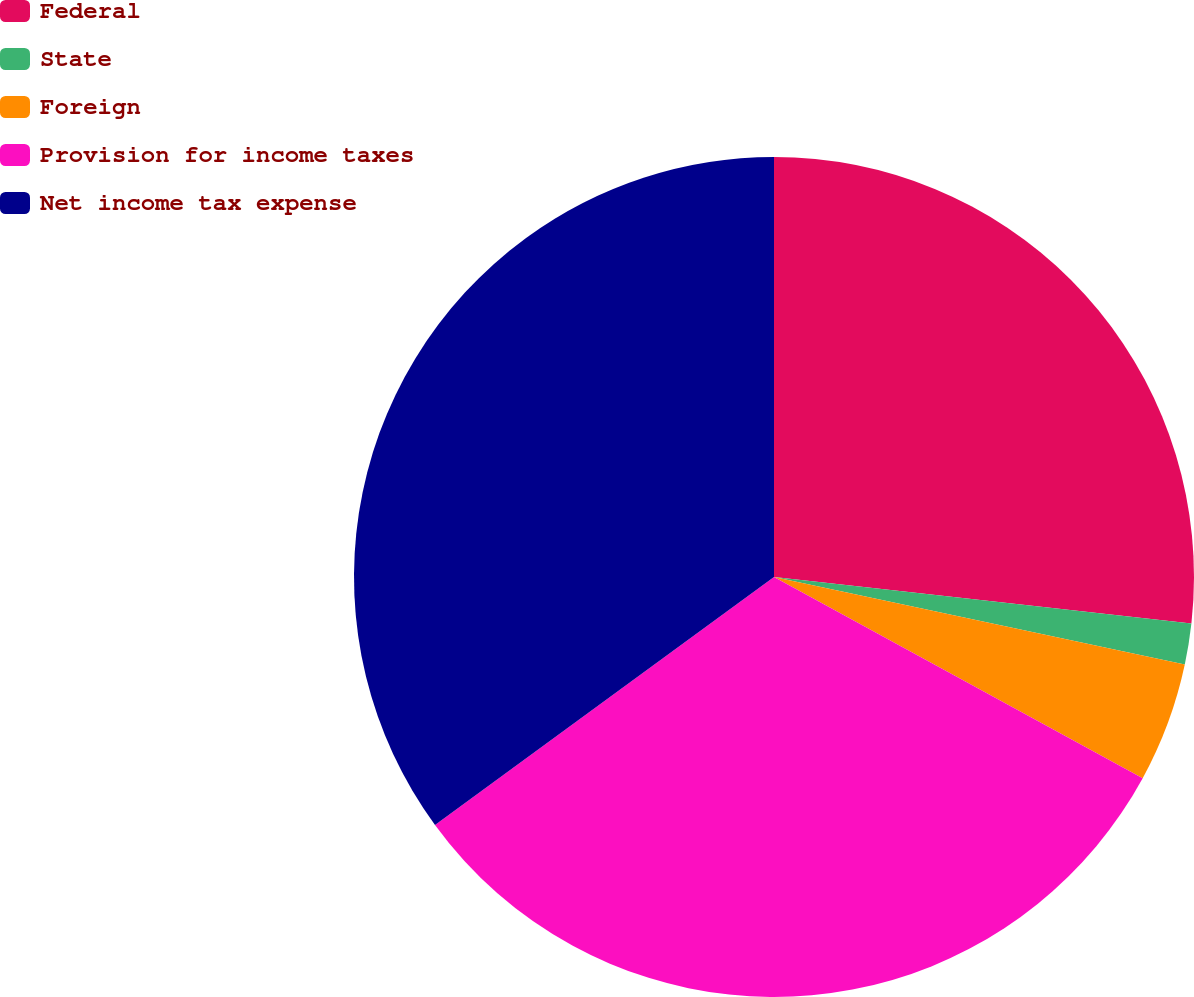Convert chart to OTSL. <chart><loc_0><loc_0><loc_500><loc_500><pie_chart><fcel>Federal<fcel>State<fcel>Foreign<fcel>Provision for income taxes<fcel>Net income tax expense<nl><fcel>26.77%<fcel>1.57%<fcel>4.61%<fcel>32.0%<fcel>35.05%<nl></chart> 